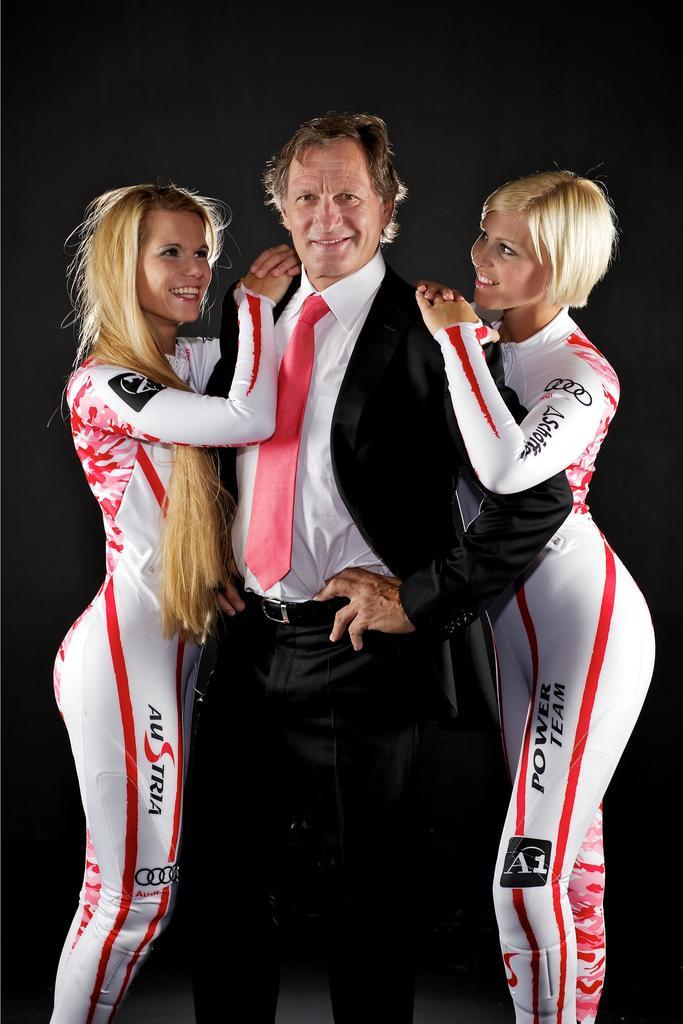<image>
Give a short and clear explanation of the subsequent image. Two Austrian Power Team women in tight body suits embrace a man in a suit. 